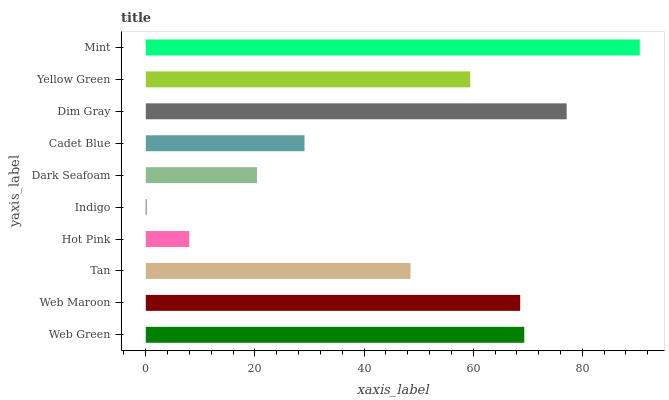Is Indigo the minimum?
Answer yes or no. Yes. Is Mint the maximum?
Answer yes or no. Yes. Is Web Maroon the minimum?
Answer yes or no. No. Is Web Maroon the maximum?
Answer yes or no. No. Is Web Green greater than Web Maroon?
Answer yes or no. Yes. Is Web Maroon less than Web Green?
Answer yes or no. Yes. Is Web Maroon greater than Web Green?
Answer yes or no. No. Is Web Green less than Web Maroon?
Answer yes or no. No. Is Yellow Green the high median?
Answer yes or no. Yes. Is Tan the low median?
Answer yes or no. Yes. Is Web Maroon the high median?
Answer yes or no. No. Is Indigo the low median?
Answer yes or no. No. 